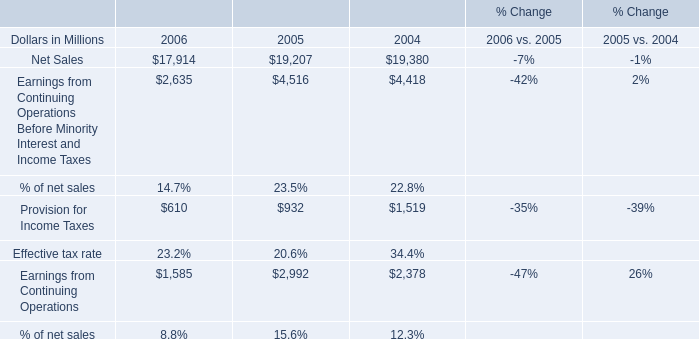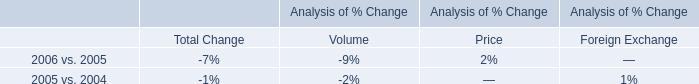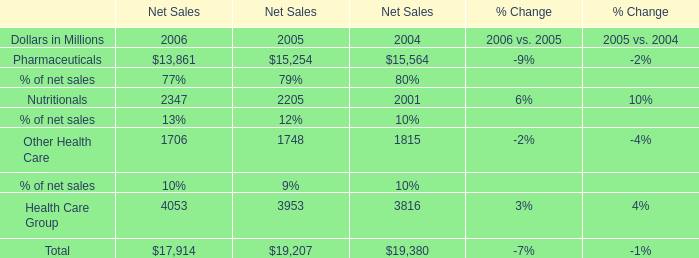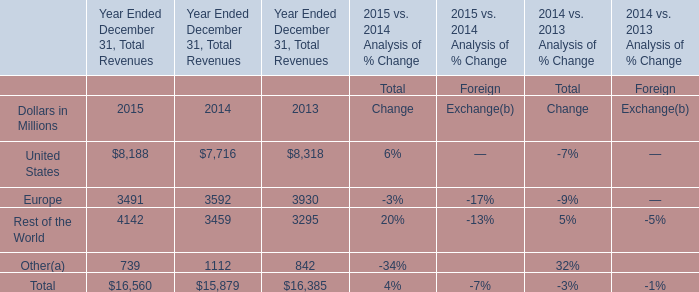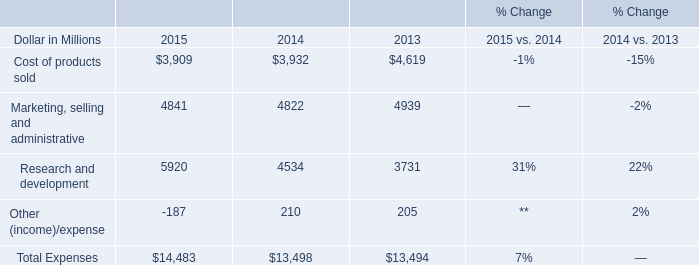What's the average of the Net Sales in the years where Earnings from Continuing Operations Before Minority Interest and Income Taxes is positive? (in million) 
Computations: (((17914 + 19207) + 19380) / 3)
Answer: 18833.66667. 